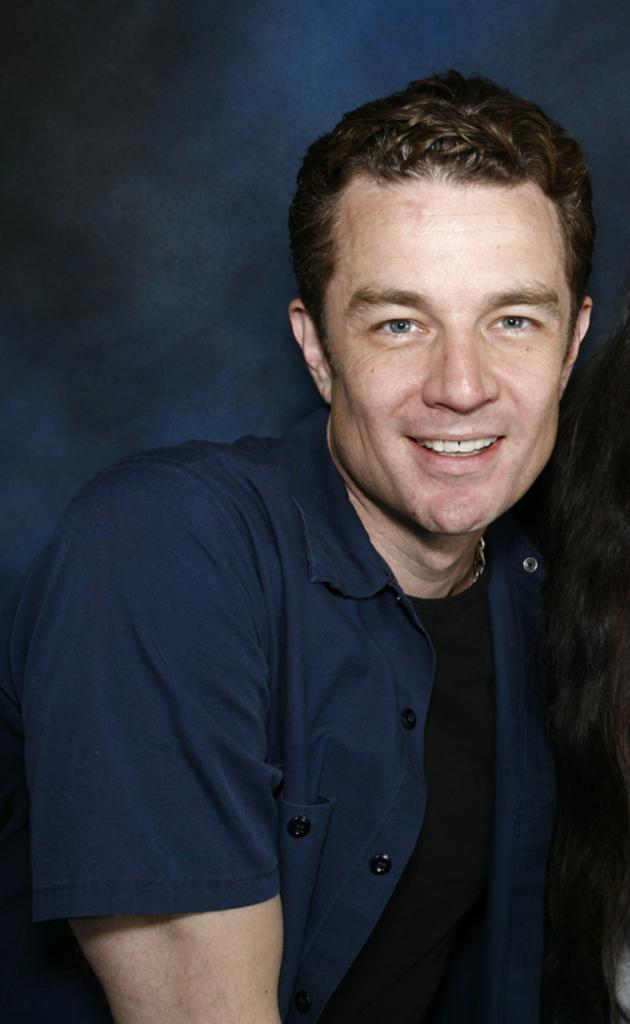What is present in the image? There is a person in the image. Can you describe the person? The person is a man. What is the man wearing? The man is wearing a navy blue shirt. What expression does the man have? The man is smiling. What type of fight is the man engaged in with the woman in the image? There is no woman present in the image, and the man is not engaged in a fight. 